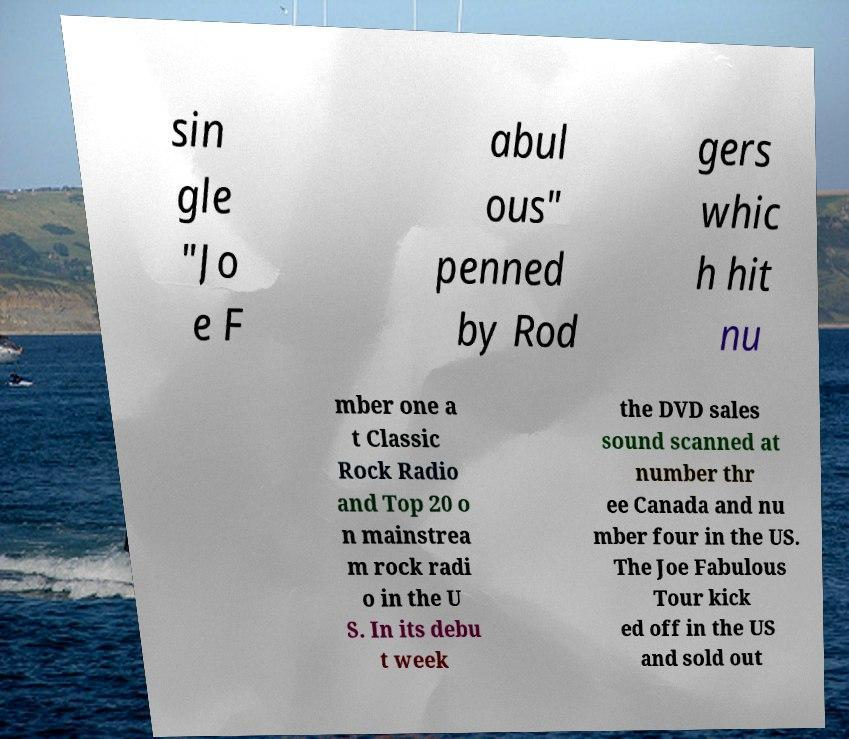There's text embedded in this image that I need extracted. Can you transcribe it verbatim? sin gle "Jo e F abul ous" penned by Rod gers whic h hit nu mber one a t Classic Rock Radio and Top 20 o n mainstrea m rock radi o in the U S. In its debu t week the DVD sales sound scanned at number thr ee Canada and nu mber four in the US. The Joe Fabulous Tour kick ed off in the US and sold out 